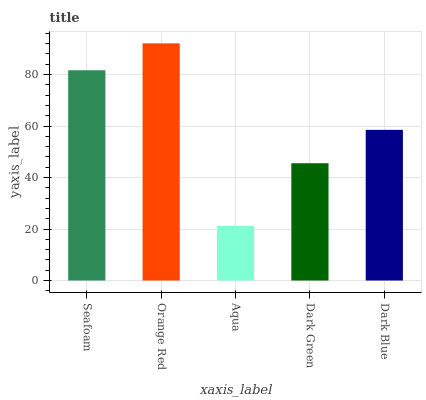Is Aqua the minimum?
Answer yes or no. Yes. Is Orange Red the maximum?
Answer yes or no. Yes. Is Orange Red the minimum?
Answer yes or no. No. Is Aqua the maximum?
Answer yes or no. No. Is Orange Red greater than Aqua?
Answer yes or no. Yes. Is Aqua less than Orange Red?
Answer yes or no. Yes. Is Aqua greater than Orange Red?
Answer yes or no. No. Is Orange Red less than Aqua?
Answer yes or no. No. Is Dark Blue the high median?
Answer yes or no. Yes. Is Dark Blue the low median?
Answer yes or no. Yes. Is Seafoam the high median?
Answer yes or no. No. Is Dark Green the low median?
Answer yes or no. No. 